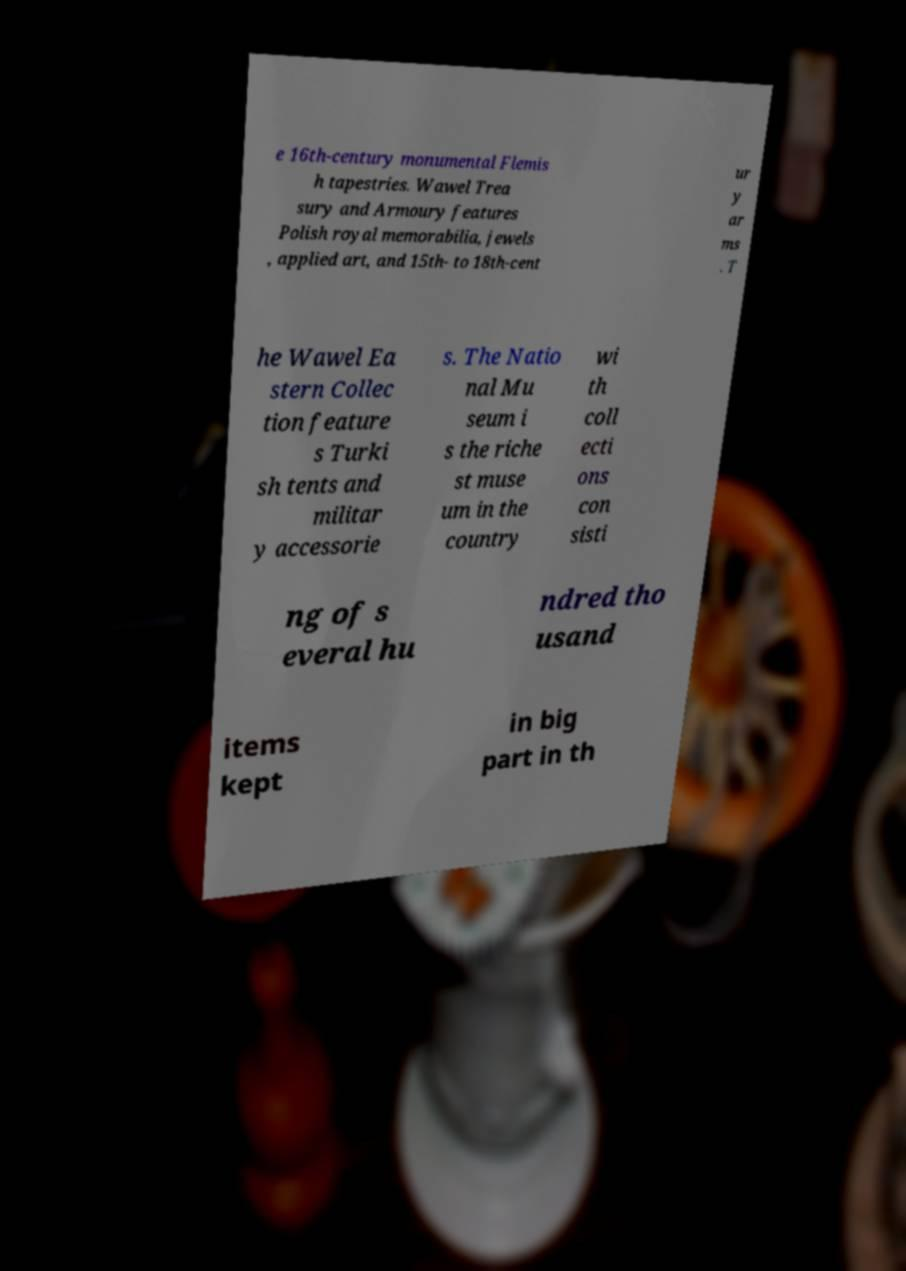For documentation purposes, I need the text within this image transcribed. Could you provide that? e 16th-century monumental Flemis h tapestries. Wawel Trea sury and Armoury features Polish royal memorabilia, jewels , applied art, and 15th- to 18th-cent ur y ar ms . T he Wawel Ea stern Collec tion feature s Turki sh tents and militar y accessorie s. The Natio nal Mu seum i s the riche st muse um in the country wi th coll ecti ons con sisti ng of s everal hu ndred tho usand items kept in big part in th 